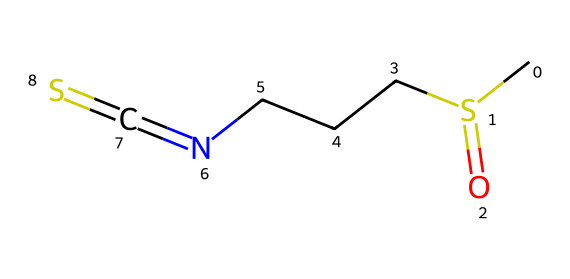What is the molecular formula of this compound? By examining the SMILES representation, we can summarize the elemental composition. The compound has one carbon from the "C", one sulfur from "S(=O)", three carbons from "CCCN", one nitrogen from "N", and one sulfur from "=S". Adding these gives a total molecular formula of C4H8N2OS2 (which summarizes the respective numbers of each atom).
Answer: C4H8N2OS2 How many sulfur atoms are present in the structure? The SMILES notation includes two "S" characters: one in "CS(=O)" and the other at the end "=S". Therefore, it is clear that there are two sulfur atoms in the structure.
Answer: 2 What type of functional group is present in this compound? Looking at the "S(=O)" in the SMILES, we can identify it as a sulfonyl group, which is characteristic of organosulfur compounds. Additionally, the presence of the thiourea linkage "N=C=S" indicates the presence of a isothiocyanate functional group. Thus, the compound contains both sulfonyl and isothiocyanate groups.
Answer: sulfonyl and isothiocyanate Which part of the molecule is responsible for its potential UV-protective properties? The isothiocyanate functional group "N=C=S" is known to have protective properties against UV light. This is due to its ability to absorb UV radiation and activate protective skin responses. Additionally, organosulfur compounds including those with this group have been associated with antioxidant activities, contributing to UV protection.
Answer: isothiocyanate What is the total number of carbon atoms in the structure? The SMILES notation contains "CCCN" which indicates the presence of three carbon atoms, and there’s one additional carbon from "C", leading to a total of four carbon atoms.
Answer: 4 